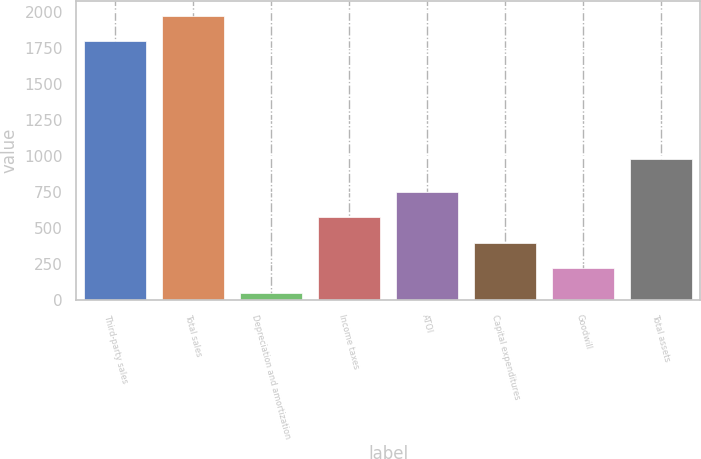Convert chart. <chart><loc_0><loc_0><loc_500><loc_500><bar_chart><fcel>Third-party sales<fcel>Total sales<fcel>Depreciation and amortization<fcel>Income taxes<fcel>ATOI<fcel>Capital expenditures<fcel>Goodwill<fcel>Total assets<nl><fcel>1802<fcel>1977.4<fcel>48<fcel>574.2<fcel>749.6<fcel>398.8<fcel>223.4<fcel>982<nl></chart> 